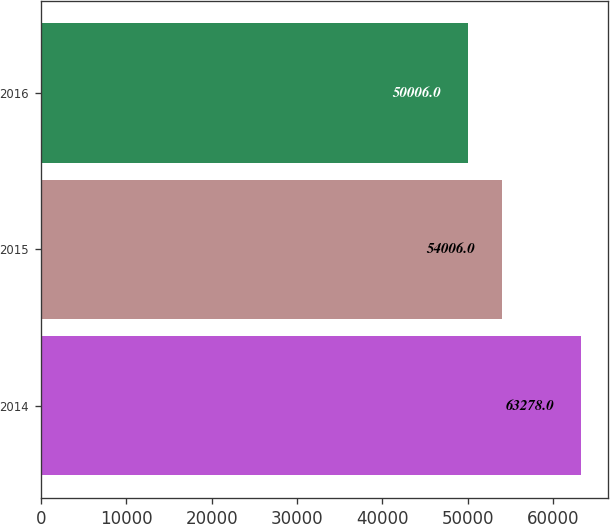Convert chart. <chart><loc_0><loc_0><loc_500><loc_500><bar_chart><fcel>2014<fcel>2015<fcel>2016<nl><fcel>63278<fcel>54006<fcel>50006<nl></chart> 